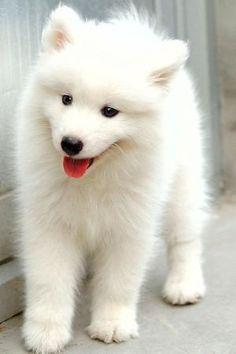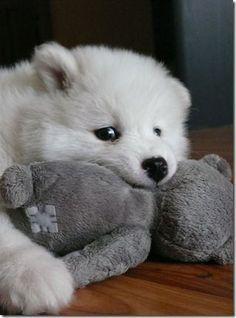The first image is the image on the left, the second image is the image on the right. Evaluate the accuracy of this statement regarding the images: "A person is posing with a white dog.". Is it true? Answer yes or no. No. The first image is the image on the left, the second image is the image on the right. For the images displayed, is the sentence "At least one image shows a person next to a big white dog." factually correct? Answer yes or no. No. 